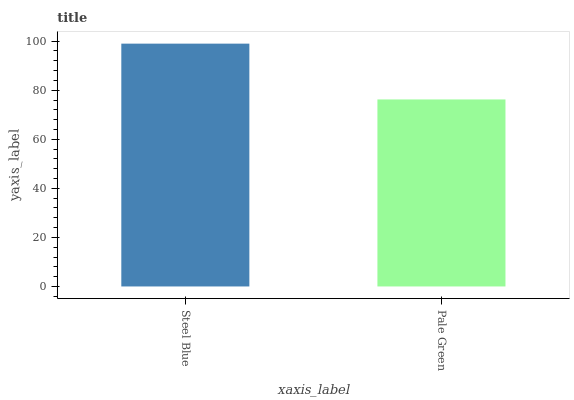Is Pale Green the minimum?
Answer yes or no. Yes. Is Steel Blue the maximum?
Answer yes or no. Yes. Is Pale Green the maximum?
Answer yes or no. No. Is Steel Blue greater than Pale Green?
Answer yes or no. Yes. Is Pale Green less than Steel Blue?
Answer yes or no. Yes. Is Pale Green greater than Steel Blue?
Answer yes or no. No. Is Steel Blue less than Pale Green?
Answer yes or no. No. Is Steel Blue the high median?
Answer yes or no. Yes. Is Pale Green the low median?
Answer yes or no. Yes. Is Pale Green the high median?
Answer yes or no. No. Is Steel Blue the low median?
Answer yes or no. No. 